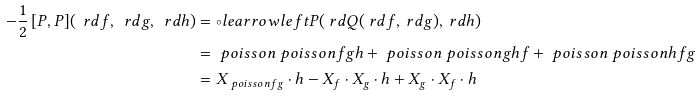Convert formula to latex. <formula><loc_0><loc_0><loc_500><loc_500>- \frac { 1 } { 2 } \, [ P , P ] ( \ r d f , \ r d g , \ r d h ) & = \circ l e a r r o w l e f t P ( \ r d Q ( \ r d f , \ r d g ) , \ r d h ) \\ & = \ p o i s s o n { \ p o i s s o n { f } { g } } { h } + \ p o i s s o n { \ p o i s s o n { g } { h } } { f } + \ p o i s s o n { \ p o i s s o n { h } { f } } { g } \\ & = X _ { \ p o i s s o n { f } { g } } \cdot h - X _ { f } \cdot X _ { g } \cdot h + X _ { g } \cdot X _ { f } \cdot h</formula> 